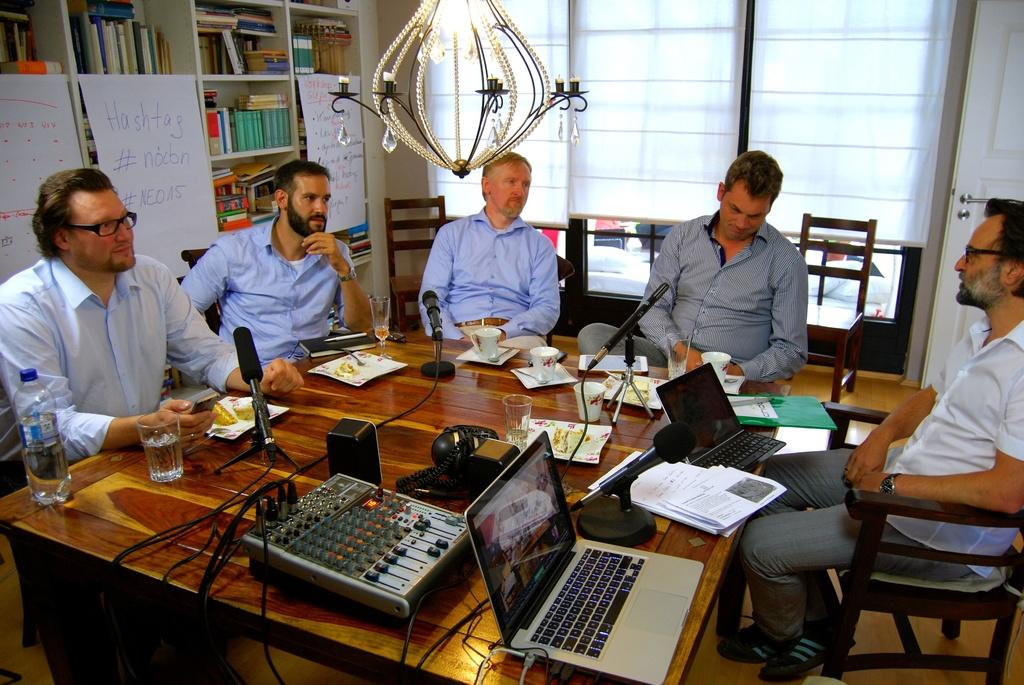How many people are in the image? There are five men in the image. What are the men doing in the image? The men are sitting on chairs. How are the chairs arranged in the image? The chairs are arranged around a table. What can be seen in the background of the image? There are books on a shelf in the background. What is the rate at which the snake is moving in the image? There is no snake present in the image, so it is not possible to determine its movement or rate. 